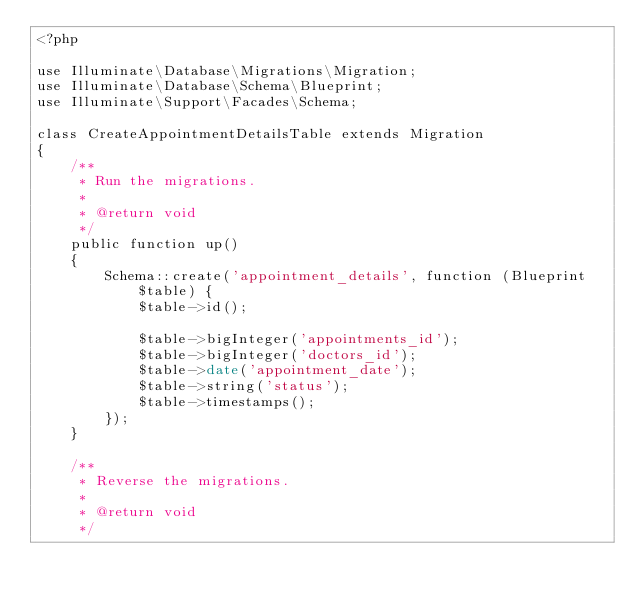<code> <loc_0><loc_0><loc_500><loc_500><_PHP_><?php

use Illuminate\Database\Migrations\Migration;
use Illuminate\Database\Schema\Blueprint;
use Illuminate\Support\Facades\Schema;

class CreateAppointmentDetailsTable extends Migration
{
    /**
     * Run the migrations.
     *
     * @return void
     */
    public function up()
    {
        Schema::create('appointment_details', function (Blueprint $table) {
            $table->id();

            $table->bigInteger('appointments_id');
            $table->bigInteger('doctors_id');
            $table->date('appointment_date');
            $table->string('status');
            $table->timestamps();
        });
    }

    /**
     * Reverse the migrations.
     *
     * @return void
     */</code> 